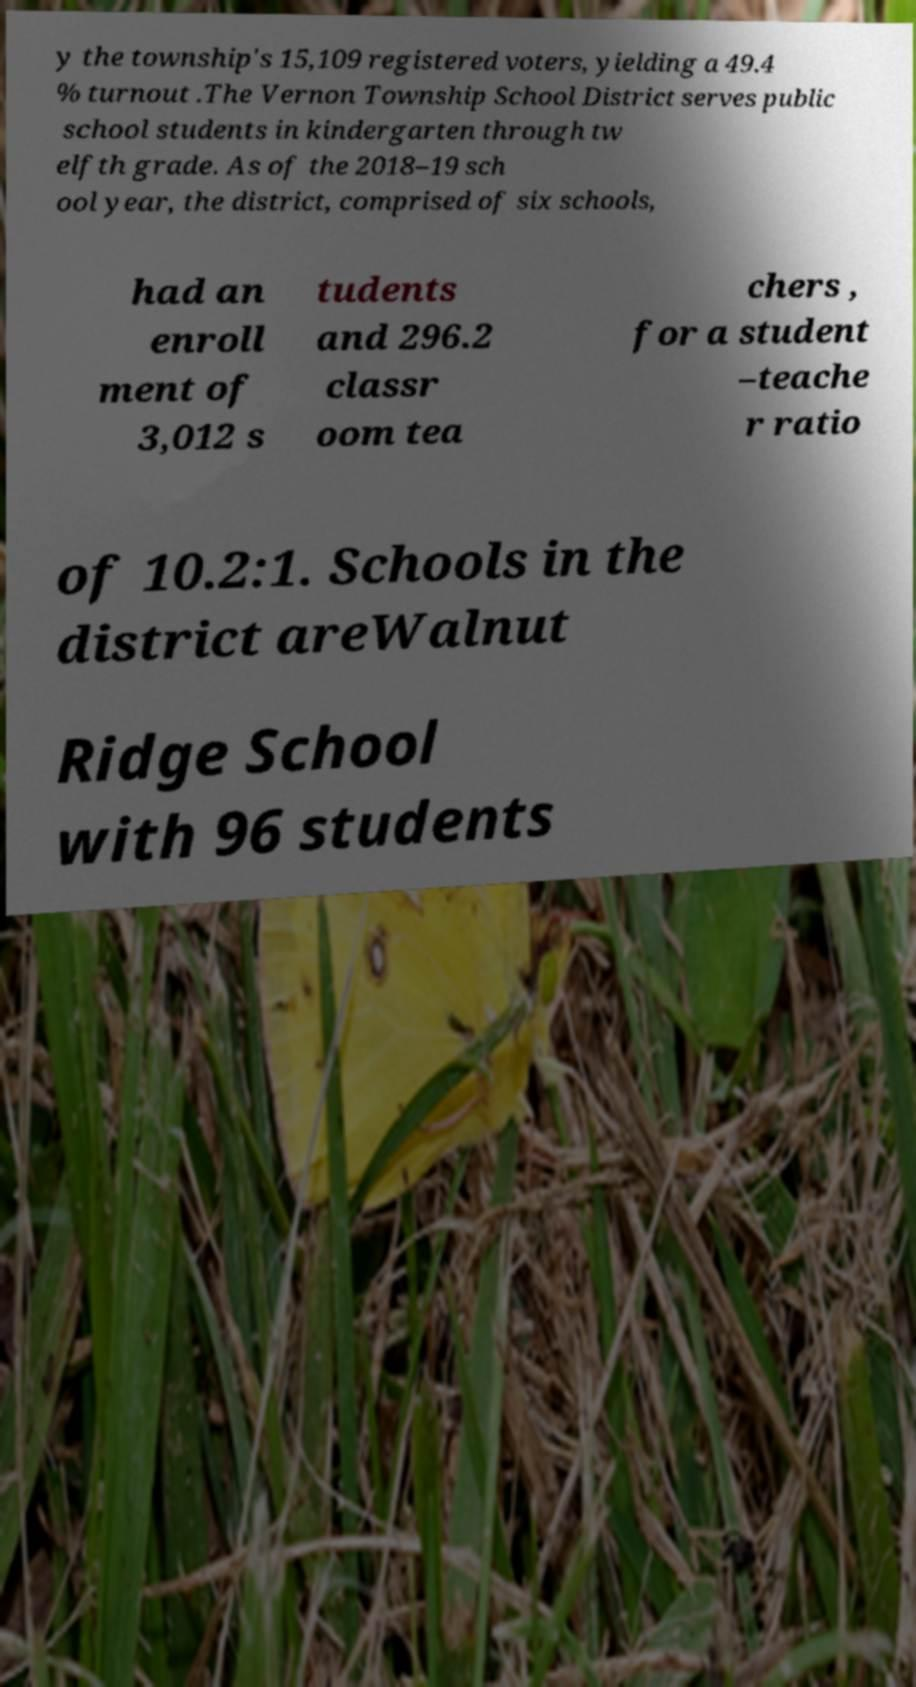Could you assist in decoding the text presented in this image and type it out clearly? y the township's 15,109 registered voters, yielding a 49.4 % turnout .The Vernon Township School District serves public school students in kindergarten through tw elfth grade. As of the 2018–19 sch ool year, the district, comprised of six schools, had an enroll ment of 3,012 s tudents and 296.2 classr oom tea chers , for a student –teache r ratio of 10.2:1. Schools in the district areWalnut Ridge School with 96 students 